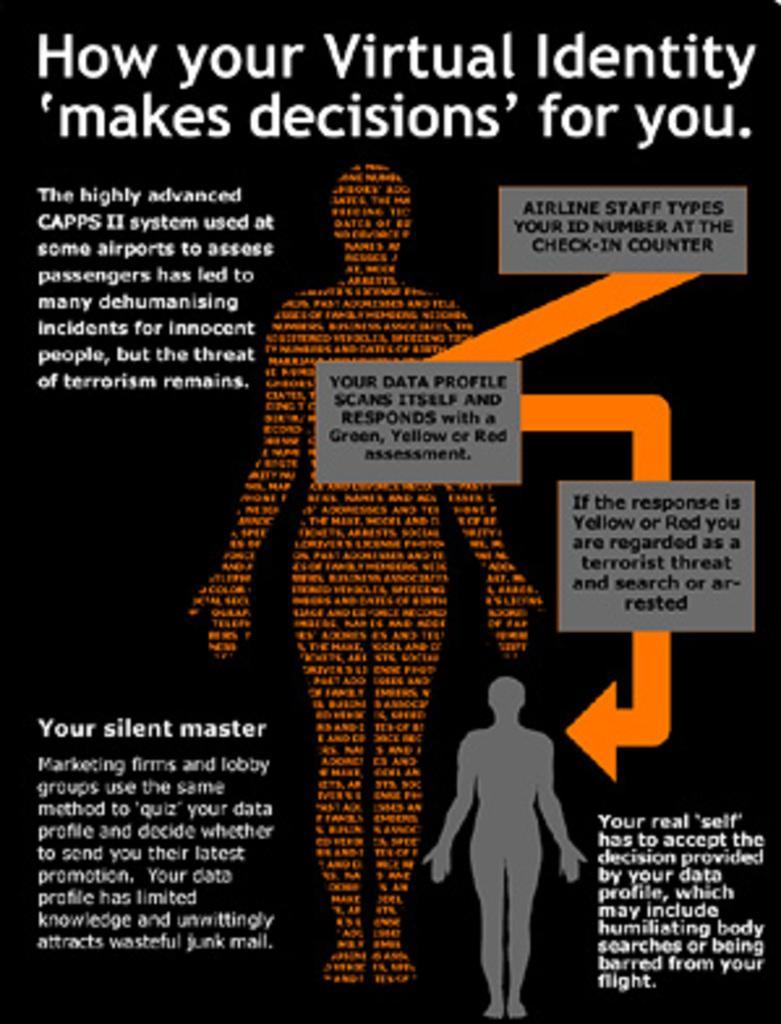How would you summarize this image in a sentence or two? In this image there is a poster. On the poster there is text. There are models of a human body. 